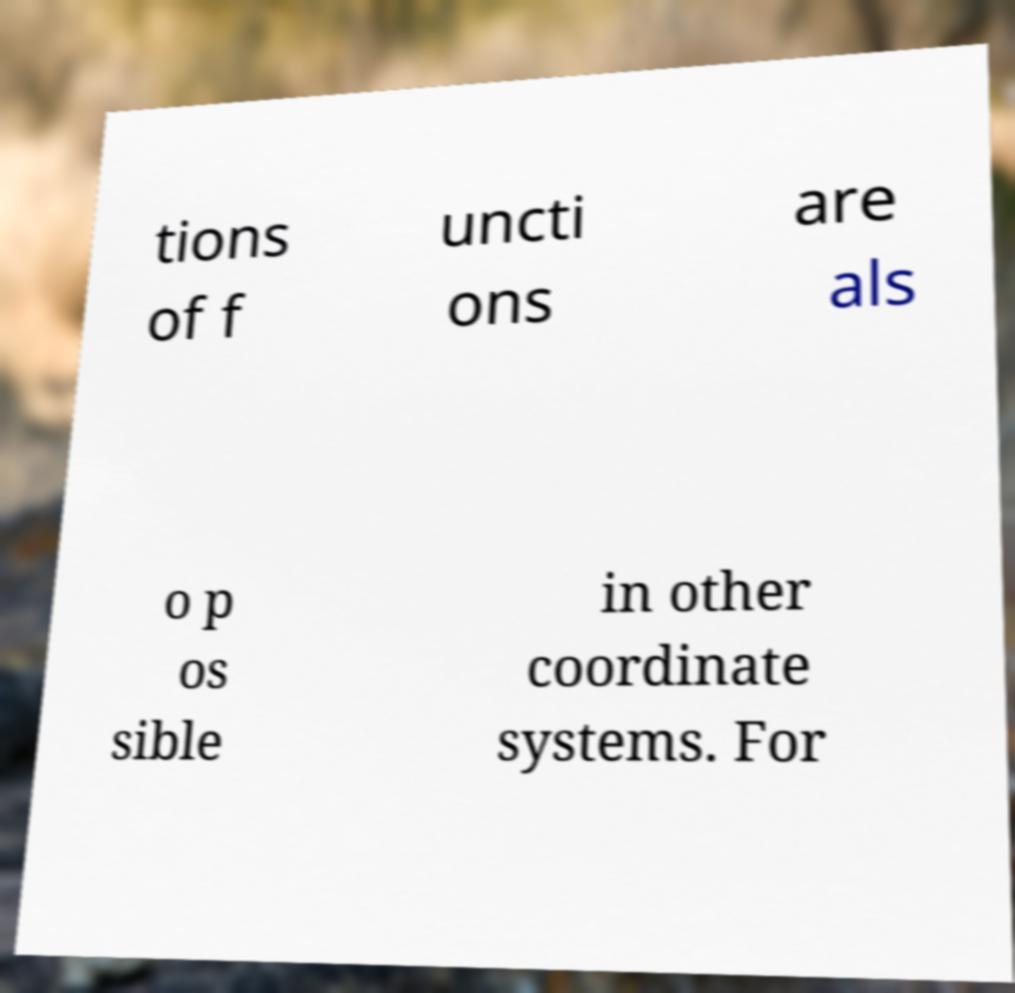Please identify and transcribe the text found in this image. tions of f uncti ons are als o p os sible in other coordinate systems. For 